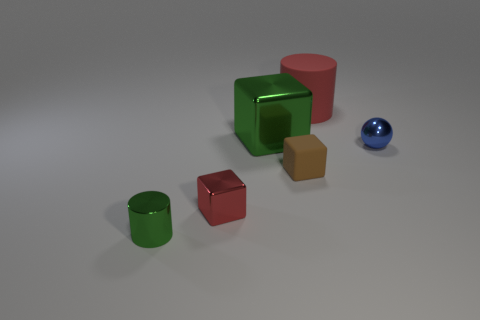The other metallic object that is the same color as the big metallic thing is what shape?
Ensure brevity in your answer.  Cylinder. There is a block that is behind the tiny cube to the right of the red cube; what color is it?
Keep it short and to the point. Green. Do the red metal object and the blue metal object have the same size?
Provide a succinct answer. Yes. How many cubes are either tiny brown rubber things or tiny purple metallic things?
Keep it short and to the point. 1. What number of small balls are behind the big cylinder that is behind the small red metal block?
Offer a very short reply. 0. Does the big red object have the same shape as the brown rubber object?
Your response must be concise. No. What is the size of the red shiny object that is the same shape as the tiny brown thing?
Offer a very short reply. Small. There is a metal object in front of the red object left of the big matte cylinder; what is its shape?
Keep it short and to the point. Cylinder. How big is the brown rubber cube?
Keep it short and to the point. Small. The large red matte object is what shape?
Keep it short and to the point. Cylinder. 